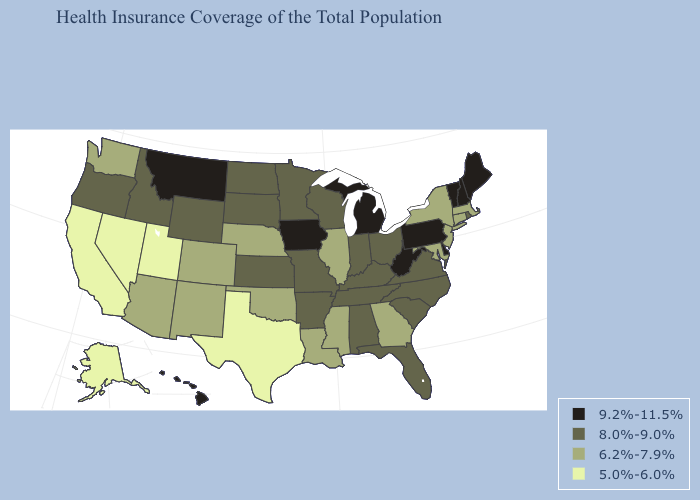Does the map have missing data?
Keep it brief. No. Name the states that have a value in the range 8.0%-9.0%?
Answer briefly. Alabama, Arkansas, Florida, Idaho, Indiana, Kansas, Kentucky, Minnesota, Missouri, North Carolina, North Dakota, Ohio, Oregon, Rhode Island, South Carolina, South Dakota, Tennessee, Virginia, Wisconsin, Wyoming. Name the states that have a value in the range 9.2%-11.5%?
Give a very brief answer. Delaware, Hawaii, Iowa, Maine, Michigan, Montana, New Hampshire, Pennsylvania, Vermont, West Virginia. Does Kansas have the highest value in the MidWest?
Give a very brief answer. No. What is the highest value in states that border New Mexico?
Short answer required. 6.2%-7.9%. Does Nevada have the highest value in the USA?
Answer briefly. No. Does Rhode Island have a lower value than Iowa?
Short answer required. Yes. Name the states that have a value in the range 5.0%-6.0%?
Be succinct. Alaska, California, Nevada, Texas, Utah. Name the states that have a value in the range 5.0%-6.0%?
Quick response, please. Alaska, California, Nevada, Texas, Utah. What is the lowest value in the MidWest?
Quick response, please. 6.2%-7.9%. Does Pennsylvania have a higher value than Maine?
Give a very brief answer. No. Does Minnesota have the lowest value in the USA?
Keep it brief. No. What is the value of Mississippi?
Be succinct. 6.2%-7.9%. Does California have the lowest value in the USA?
Keep it brief. Yes. 